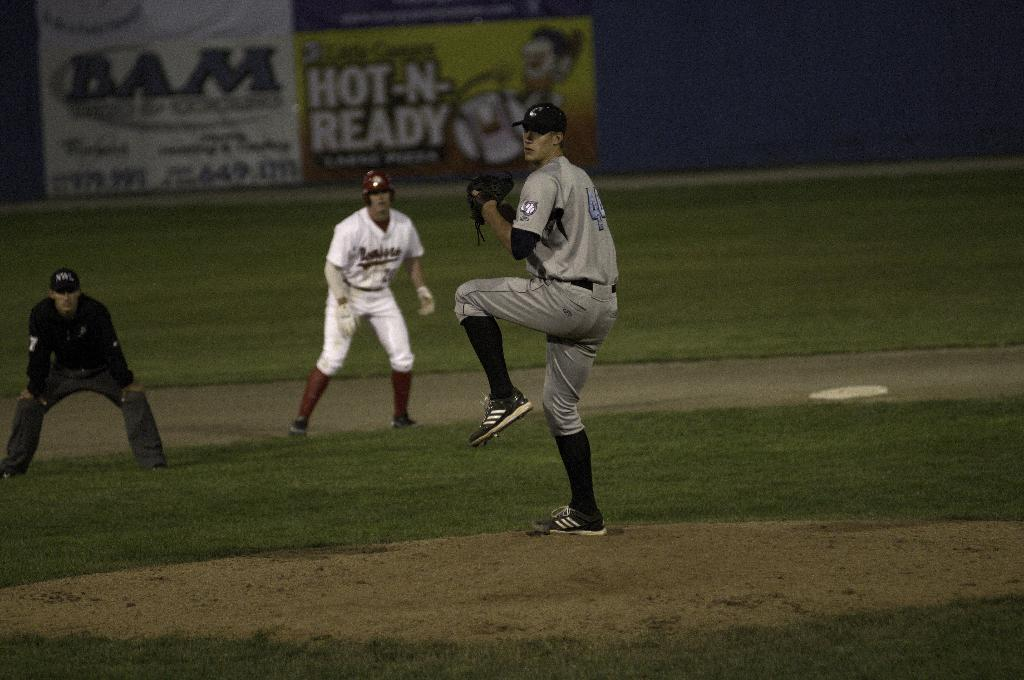<image>
Summarize the visual content of the image. A pitcher is about to throw a ball with a Hot-N-Ready sign behind. 